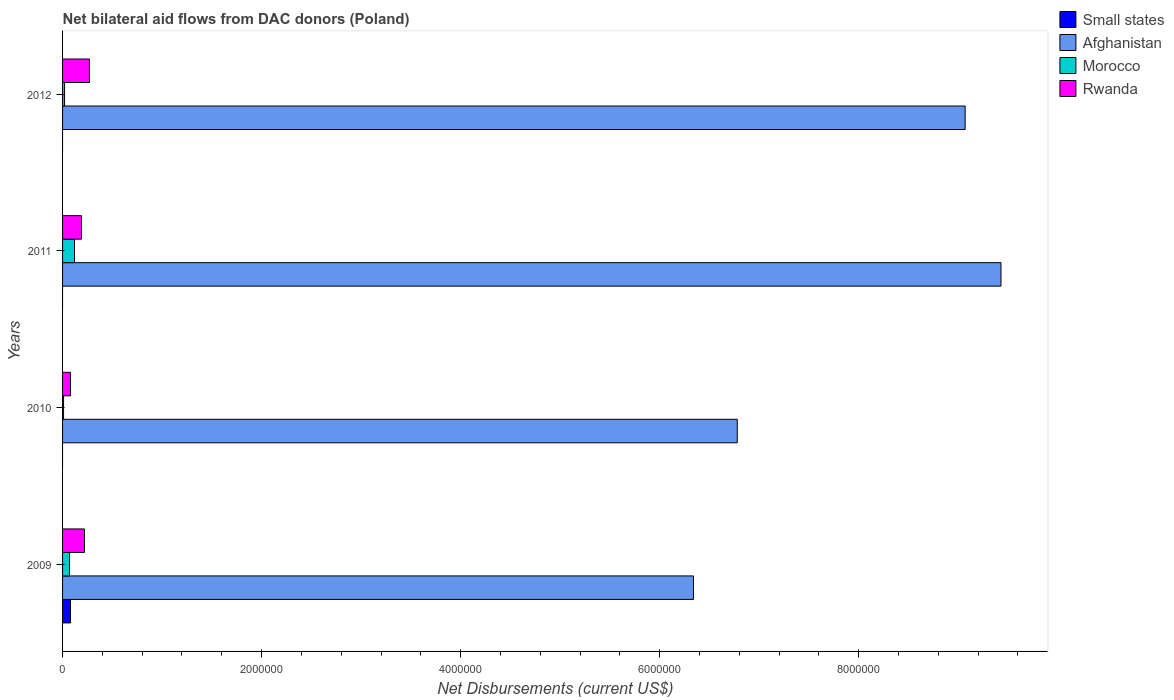How many groups of bars are there?
Provide a succinct answer. 4. Are the number of bars per tick equal to the number of legend labels?
Your answer should be compact. No. How many bars are there on the 2nd tick from the top?
Give a very brief answer. 3. How many bars are there on the 4th tick from the bottom?
Give a very brief answer. 3. What is the net bilateral aid flows in Small states in 2012?
Offer a terse response. 0. Across all years, what is the maximum net bilateral aid flows in Morocco?
Provide a short and direct response. 1.20e+05. In which year was the net bilateral aid flows in Small states maximum?
Keep it short and to the point. 2009. What is the difference between the net bilateral aid flows in Morocco in 2010 and that in 2012?
Offer a terse response. -10000. What is the difference between the net bilateral aid flows in Afghanistan in 2009 and the net bilateral aid flows in Rwanda in 2011?
Offer a very short reply. 6.15e+06. What is the average net bilateral aid flows in Small states per year?
Provide a succinct answer. 2.00e+04. In the year 2012, what is the difference between the net bilateral aid flows in Afghanistan and net bilateral aid flows in Rwanda?
Offer a very short reply. 8.80e+06. In how many years, is the net bilateral aid flows in Small states greater than 8000000 US$?
Keep it short and to the point. 0. What is the ratio of the net bilateral aid flows in Afghanistan in 2009 to that in 2011?
Ensure brevity in your answer.  0.67. What is the difference between the highest and the lowest net bilateral aid flows in Rwanda?
Your answer should be compact. 1.90e+05. Is it the case that in every year, the sum of the net bilateral aid flows in Small states and net bilateral aid flows in Morocco is greater than the net bilateral aid flows in Rwanda?
Your response must be concise. No. Are the values on the major ticks of X-axis written in scientific E-notation?
Give a very brief answer. No. Where does the legend appear in the graph?
Keep it short and to the point. Top right. How are the legend labels stacked?
Provide a succinct answer. Vertical. What is the title of the graph?
Offer a terse response. Net bilateral aid flows from DAC donors (Poland). What is the label or title of the X-axis?
Provide a succinct answer. Net Disbursements (current US$). What is the label or title of the Y-axis?
Make the answer very short. Years. What is the Net Disbursements (current US$) in Small states in 2009?
Your answer should be compact. 8.00e+04. What is the Net Disbursements (current US$) of Afghanistan in 2009?
Provide a short and direct response. 6.34e+06. What is the Net Disbursements (current US$) of Rwanda in 2009?
Your answer should be compact. 2.20e+05. What is the Net Disbursements (current US$) in Afghanistan in 2010?
Your answer should be very brief. 6.78e+06. What is the Net Disbursements (current US$) of Afghanistan in 2011?
Offer a very short reply. 9.43e+06. What is the Net Disbursements (current US$) of Morocco in 2011?
Provide a succinct answer. 1.20e+05. What is the Net Disbursements (current US$) in Rwanda in 2011?
Give a very brief answer. 1.90e+05. What is the Net Disbursements (current US$) in Small states in 2012?
Ensure brevity in your answer.  0. What is the Net Disbursements (current US$) of Afghanistan in 2012?
Offer a terse response. 9.07e+06. Across all years, what is the maximum Net Disbursements (current US$) in Small states?
Provide a succinct answer. 8.00e+04. Across all years, what is the maximum Net Disbursements (current US$) in Afghanistan?
Give a very brief answer. 9.43e+06. Across all years, what is the minimum Net Disbursements (current US$) of Afghanistan?
Provide a short and direct response. 6.34e+06. Across all years, what is the minimum Net Disbursements (current US$) of Morocco?
Provide a succinct answer. 10000. Across all years, what is the minimum Net Disbursements (current US$) of Rwanda?
Your answer should be compact. 8.00e+04. What is the total Net Disbursements (current US$) in Afghanistan in the graph?
Your answer should be compact. 3.16e+07. What is the total Net Disbursements (current US$) of Rwanda in the graph?
Give a very brief answer. 7.60e+05. What is the difference between the Net Disbursements (current US$) in Afghanistan in 2009 and that in 2010?
Your response must be concise. -4.40e+05. What is the difference between the Net Disbursements (current US$) of Morocco in 2009 and that in 2010?
Your answer should be very brief. 6.00e+04. What is the difference between the Net Disbursements (current US$) in Rwanda in 2009 and that in 2010?
Ensure brevity in your answer.  1.40e+05. What is the difference between the Net Disbursements (current US$) of Afghanistan in 2009 and that in 2011?
Offer a very short reply. -3.09e+06. What is the difference between the Net Disbursements (current US$) in Morocco in 2009 and that in 2011?
Ensure brevity in your answer.  -5.00e+04. What is the difference between the Net Disbursements (current US$) in Afghanistan in 2009 and that in 2012?
Your response must be concise. -2.73e+06. What is the difference between the Net Disbursements (current US$) of Morocco in 2009 and that in 2012?
Offer a very short reply. 5.00e+04. What is the difference between the Net Disbursements (current US$) in Afghanistan in 2010 and that in 2011?
Offer a very short reply. -2.65e+06. What is the difference between the Net Disbursements (current US$) of Rwanda in 2010 and that in 2011?
Your response must be concise. -1.10e+05. What is the difference between the Net Disbursements (current US$) of Afghanistan in 2010 and that in 2012?
Provide a short and direct response. -2.29e+06. What is the difference between the Net Disbursements (current US$) in Rwanda in 2010 and that in 2012?
Offer a very short reply. -1.90e+05. What is the difference between the Net Disbursements (current US$) in Afghanistan in 2011 and that in 2012?
Keep it short and to the point. 3.60e+05. What is the difference between the Net Disbursements (current US$) of Small states in 2009 and the Net Disbursements (current US$) of Afghanistan in 2010?
Ensure brevity in your answer.  -6.70e+06. What is the difference between the Net Disbursements (current US$) in Small states in 2009 and the Net Disbursements (current US$) in Morocco in 2010?
Give a very brief answer. 7.00e+04. What is the difference between the Net Disbursements (current US$) of Afghanistan in 2009 and the Net Disbursements (current US$) of Morocco in 2010?
Offer a terse response. 6.33e+06. What is the difference between the Net Disbursements (current US$) of Afghanistan in 2009 and the Net Disbursements (current US$) of Rwanda in 2010?
Provide a short and direct response. 6.26e+06. What is the difference between the Net Disbursements (current US$) of Small states in 2009 and the Net Disbursements (current US$) of Afghanistan in 2011?
Offer a terse response. -9.35e+06. What is the difference between the Net Disbursements (current US$) in Small states in 2009 and the Net Disbursements (current US$) in Morocco in 2011?
Provide a short and direct response. -4.00e+04. What is the difference between the Net Disbursements (current US$) of Small states in 2009 and the Net Disbursements (current US$) of Rwanda in 2011?
Your response must be concise. -1.10e+05. What is the difference between the Net Disbursements (current US$) of Afghanistan in 2009 and the Net Disbursements (current US$) of Morocco in 2011?
Offer a terse response. 6.22e+06. What is the difference between the Net Disbursements (current US$) in Afghanistan in 2009 and the Net Disbursements (current US$) in Rwanda in 2011?
Your response must be concise. 6.15e+06. What is the difference between the Net Disbursements (current US$) in Small states in 2009 and the Net Disbursements (current US$) in Afghanistan in 2012?
Make the answer very short. -8.99e+06. What is the difference between the Net Disbursements (current US$) in Small states in 2009 and the Net Disbursements (current US$) in Morocco in 2012?
Make the answer very short. 6.00e+04. What is the difference between the Net Disbursements (current US$) of Small states in 2009 and the Net Disbursements (current US$) of Rwanda in 2012?
Your answer should be compact. -1.90e+05. What is the difference between the Net Disbursements (current US$) in Afghanistan in 2009 and the Net Disbursements (current US$) in Morocco in 2012?
Ensure brevity in your answer.  6.32e+06. What is the difference between the Net Disbursements (current US$) in Afghanistan in 2009 and the Net Disbursements (current US$) in Rwanda in 2012?
Your answer should be very brief. 6.07e+06. What is the difference between the Net Disbursements (current US$) of Morocco in 2009 and the Net Disbursements (current US$) of Rwanda in 2012?
Provide a succinct answer. -2.00e+05. What is the difference between the Net Disbursements (current US$) in Afghanistan in 2010 and the Net Disbursements (current US$) in Morocco in 2011?
Offer a very short reply. 6.66e+06. What is the difference between the Net Disbursements (current US$) in Afghanistan in 2010 and the Net Disbursements (current US$) in Rwanda in 2011?
Keep it short and to the point. 6.59e+06. What is the difference between the Net Disbursements (current US$) in Morocco in 2010 and the Net Disbursements (current US$) in Rwanda in 2011?
Provide a succinct answer. -1.80e+05. What is the difference between the Net Disbursements (current US$) of Afghanistan in 2010 and the Net Disbursements (current US$) of Morocco in 2012?
Keep it short and to the point. 6.76e+06. What is the difference between the Net Disbursements (current US$) of Afghanistan in 2010 and the Net Disbursements (current US$) of Rwanda in 2012?
Your answer should be compact. 6.51e+06. What is the difference between the Net Disbursements (current US$) in Morocco in 2010 and the Net Disbursements (current US$) in Rwanda in 2012?
Offer a terse response. -2.60e+05. What is the difference between the Net Disbursements (current US$) in Afghanistan in 2011 and the Net Disbursements (current US$) in Morocco in 2012?
Ensure brevity in your answer.  9.41e+06. What is the difference between the Net Disbursements (current US$) of Afghanistan in 2011 and the Net Disbursements (current US$) of Rwanda in 2012?
Provide a succinct answer. 9.16e+06. What is the difference between the Net Disbursements (current US$) in Morocco in 2011 and the Net Disbursements (current US$) in Rwanda in 2012?
Your answer should be compact. -1.50e+05. What is the average Net Disbursements (current US$) of Small states per year?
Your answer should be compact. 2.00e+04. What is the average Net Disbursements (current US$) of Afghanistan per year?
Your answer should be compact. 7.90e+06. What is the average Net Disbursements (current US$) in Morocco per year?
Give a very brief answer. 5.50e+04. In the year 2009, what is the difference between the Net Disbursements (current US$) in Small states and Net Disbursements (current US$) in Afghanistan?
Offer a terse response. -6.26e+06. In the year 2009, what is the difference between the Net Disbursements (current US$) in Small states and Net Disbursements (current US$) in Morocco?
Make the answer very short. 10000. In the year 2009, what is the difference between the Net Disbursements (current US$) of Afghanistan and Net Disbursements (current US$) of Morocco?
Provide a short and direct response. 6.27e+06. In the year 2009, what is the difference between the Net Disbursements (current US$) in Afghanistan and Net Disbursements (current US$) in Rwanda?
Keep it short and to the point. 6.12e+06. In the year 2009, what is the difference between the Net Disbursements (current US$) in Morocco and Net Disbursements (current US$) in Rwanda?
Your answer should be compact. -1.50e+05. In the year 2010, what is the difference between the Net Disbursements (current US$) of Afghanistan and Net Disbursements (current US$) of Morocco?
Offer a terse response. 6.77e+06. In the year 2010, what is the difference between the Net Disbursements (current US$) of Afghanistan and Net Disbursements (current US$) of Rwanda?
Provide a succinct answer. 6.70e+06. In the year 2011, what is the difference between the Net Disbursements (current US$) in Afghanistan and Net Disbursements (current US$) in Morocco?
Provide a succinct answer. 9.31e+06. In the year 2011, what is the difference between the Net Disbursements (current US$) of Afghanistan and Net Disbursements (current US$) of Rwanda?
Provide a short and direct response. 9.24e+06. In the year 2011, what is the difference between the Net Disbursements (current US$) of Morocco and Net Disbursements (current US$) of Rwanda?
Your response must be concise. -7.00e+04. In the year 2012, what is the difference between the Net Disbursements (current US$) in Afghanistan and Net Disbursements (current US$) in Morocco?
Keep it short and to the point. 9.05e+06. In the year 2012, what is the difference between the Net Disbursements (current US$) of Afghanistan and Net Disbursements (current US$) of Rwanda?
Ensure brevity in your answer.  8.80e+06. In the year 2012, what is the difference between the Net Disbursements (current US$) in Morocco and Net Disbursements (current US$) in Rwanda?
Keep it short and to the point. -2.50e+05. What is the ratio of the Net Disbursements (current US$) in Afghanistan in 2009 to that in 2010?
Provide a short and direct response. 0.94. What is the ratio of the Net Disbursements (current US$) in Rwanda in 2009 to that in 2010?
Your answer should be compact. 2.75. What is the ratio of the Net Disbursements (current US$) of Afghanistan in 2009 to that in 2011?
Make the answer very short. 0.67. What is the ratio of the Net Disbursements (current US$) of Morocco in 2009 to that in 2011?
Ensure brevity in your answer.  0.58. What is the ratio of the Net Disbursements (current US$) of Rwanda in 2009 to that in 2011?
Provide a short and direct response. 1.16. What is the ratio of the Net Disbursements (current US$) of Afghanistan in 2009 to that in 2012?
Provide a short and direct response. 0.7. What is the ratio of the Net Disbursements (current US$) in Morocco in 2009 to that in 2012?
Offer a very short reply. 3.5. What is the ratio of the Net Disbursements (current US$) in Rwanda in 2009 to that in 2012?
Provide a short and direct response. 0.81. What is the ratio of the Net Disbursements (current US$) in Afghanistan in 2010 to that in 2011?
Your answer should be very brief. 0.72. What is the ratio of the Net Disbursements (current US$) in Morocco in 2010 to that in 2011?
Offer a very short reply. 0.08. What is the ratio of the Net Disbursements (current US$) in Rwanda in 2010 to that in 2011?
Your answer should be compact. 0.42. What is the ratio of the Net Disbursements (current US$) of Afghanistan in 2010 to that in 2012?
Keep it short and to the point. 0.75. What is the ratio of the Net Disbursements (current US$) of Rwanda in 2010 to that in 2012?
Provide a succinct answer. 0.3. What is the ratio of the Net Disbursements (current US$) in Afghanistan in 2011 to that in 2012?
Your response must be concise. 1.04. What is the ratio of the Net Disbursements (current US$) of Morocco in 2011 to that in 2012?
Offer a very short reply. 6. What is the ratio of the Net Disbursements (current US$) of Rwanda in 2011 to that in 2012?
Your answer should be compact. 0.7. What is the difference between the highest and the second highest Net Disbursements (current US$) of Afghanistan?
Make the answer very short. 3.60e+05. What is the difference between the highest and the lowest Net Disbursements (current US$) of Afghanistan?
Make the answer very short. 3.09e+06. 